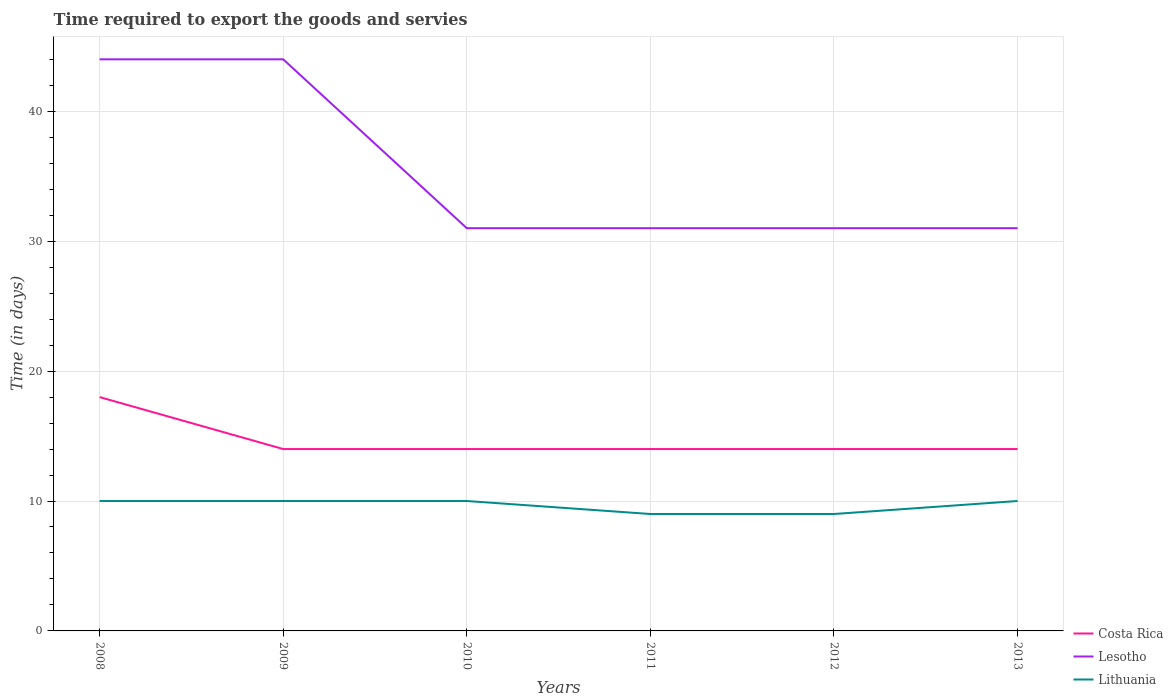Across all years, what is the maximum number of days required to export the goods and services in Lesotho?
Your answer should be very brief. 31. In which year was the number of days required to export the goods and services in Lesotho maximum?
Give a very brief answer. 2010. What is the total number of days required to export the goods and services in Lesotho in the graph?
Ensure brevity in your answer.  13. What is the difference between the highest and the second highest number of days required to export the goods and services in Lithuania?
Provide a short and direct response. 1. Is the number of days required to export the goods and services in Lithuania strictly greater than the number of days required to export the goods and services in Costa Rica over the years?
Provide a short and direct response. Yes. How many lines are there?
Keep it short and to the point. 3. How many years are there in the graph?
Give a very brief answer. 6. What is the difference between two consecutive major ticks on the Y-axis?
Provide a short and direct response. 10. Does the graph contain any zero values?
Your answer should be compact. No. Does the graph contain grids?
Offer a very short reply. Yes. What is the title of the graph?
Your response must be concise. Time required to export the goods and servies. What is the label or title of the X-axis?
Provide a succinct answer. Years. What is the label or title of the Y-axis?
Make the answer very short. Time (in days). What is the Time (in days) in Lithuania in 2008?
Provide a succinct answer. 10. What is the Time (in days) of Costa Rica in 2009?
Your answer should be very brief. 14. What is the Time (in days) of Lesotho in 2009?
Provide a succinct answer. 44. What is the Time (in days) of Costa Rica in 2011?
Provide a short and direct response. 14. What is the Time (in days) of Lesotho in 2012?
Offer a very short reply. 31. What is the Time (in days) of Lithuania in 2012?
Ensure brevity in your answer.  9. What is the Time (in days) in Costa Rica in 2013?
Offer a very short reply. 14. What is the Time (in days) of Lesotho in 2013?
Give a very brief answer. 31. What is the Time (in days) in Lithuania in 2013?
Provide a succinct answer. 10. Across all years, what is the maximum Time (in days) of Costa Rica?
Give a very brief answer. 18. Across all years, what is the maximum Time (in days) of Lesotho?
Keep it short and to the point. 44. Across all years, what is the minimum Time (in days) of Costa Rica?
Keep it short and to the point. 14. Across all years, what is the minimum Time (in days) of Lithuania?
Offer a terse response. 9. What is the total Time (in days) in Costa Rica in the graph?
Give a very brief answer. 88. What is the total Time (in days) of Lesotho in the graph?
Offer a terse response. 212. What is the total Time (in days) of Lithuania in the graph?
Your response must be concise. 58. What is the difference between the Time (in days) in Costa Rica in 2008 and that in 2009?
Give a very brief answer. 4. What is the difference between the Time (in days) of Lesotho in 2008 and that in 2009?
Your answer should be very brief. 0. What is the difference between the Time (in days) in Lithuania in 2008 and that in 2009?
Provide a succinct answer. 0. What is the difference between the Time (in days) of Lesotho in 2008 and that in 2010?
Ensure brevity in your answer.  13. What is the difference between the Time (in days) of Lithuania in 2008 and that in 2010?
Give a very brief answer. 0. What is the difference between the Time (in days) in Costa Rica in 2008 and that in 2011?
Give a very brief answer. 4. What is the difference between the Time (in days) of Lesotho in 2008 and that in 2011?
Your answer should be very brief. 13. What is the difference between the Time (in days) in Lithuania in 2008 and that in 2011?
Your answer should be very brief. 1. What is the difference between the Time (in days) of Costa Rica in 2008 and that in 2013?
Give a very brief answer. 4. What is the difference between the Time (in days) of Lesotho in 2008 and that in 2013?
Keep it short and to the point. 13. What is the difference between the Time (in days) of Lithuania in 2008 and that in 2013?
Your answer should be very brief. 0. What is the difference between the Time (in days) of Costa Rica in 2009 and that in 2010?
Give a very brief answer. 0. What is the difference between the Time (in days) in Lesotho in 2009 and that in 2010?
Provide a succinct answer. 13. What is the difference between the Time (in days) in Lithuania in 2009 and that in 2010?
Make the answer very short. 0. What is the difference between the Time (in days) in Lesotho in 2009 and that in 2011?
Keep it short and to the point. 13. What is the difference between the Time (in days) of Costa Rica in 2009 and that in 2012?
Your answer should be very brief. 0. What is the difference between the Time (in days) of Lesotho in 2009 and that in 2012?
Make the answer very short. 13. What is the difference between the Time (in days) of Lesotho in 2009 and that in 2013?
Offer a terse response. 13. What is the difference between the Time (in days) in Lithuania in 2009 and that in 2013?
Ensure brevity in your answer.  0. What is the difference between the Time (in days) of Lesotho in 2010 and that in 2011?
Give a very brief answer. 0. What is the difference between the Time (in days) in Lithuania in 2010 and that in 2011?
Offer a very short reply. 1. What is the difference between the Time (in days) in Lesotho in 2010 and that in 2012?
Provide a short and direct response. 0. What is the difference between the Time (in days) of Costa Rica in 2011 and that in 2012?
Offer a very short reply. 0. What is the difference between the Time (in days) of Lesotho in 2011 and that in 2012?
Ensure brevity in your answer.  0. What is the difference between the Time (in days) in Lithuania in 2011 and that in 2012?
Provide a succinct answer. 0. What is the difference between the Time (in days) in Costa Rica in 2011 and that in 2013?
Provide a succinct answer. 0. What is the difference between the Time (in days) in Lesotho in 2011 and that in 2013?
Offer a very short reply. 0. What is the difference between the Time (in days) of Costa Rica in 2012 and that in 2013?
Your answer should be very brief. 0. What is the difference between the Time (in days) of Lithuania in 2012 and that in 2013?
Your answer should be compact. -1. What is the difference between the Time (in days) in Costa Rica in 2008 and the Time (in days) in Lithuania in 2009?
Give a very brief answer. 8. What is the difference between the Time (in days) in Costa Rica in 2008 and the Time (in days) in Lesotho in 2010?
Provide a succinct answer. -13. What is the difference between the Time (in days) in Costa Rica in 2008 and the Time (in days) in Lithuania in 2010?
Ensure brevity in your answer.  8. What is the difference between the Time (in days) in Lesotho in 2008 and the Time (in days) in Lithuania in 2010?
Provide a short and direct response. 34. What is the difference between the Time (in days) in Costa Rica in 2008 and the Time (in days) in Lesotho in 2011?
Make the answer very short. -13. What is the difference between the Time (in days) of Lesotho in 2008 and the Time (in days) of Lithuania in 2011?
Keep it short and to the point. 35. What is the difference between the Time (in days) of Costa Rica in 2008 and the Time (in days) of Lesotho in 2012?
Give a very brief answer. -13. What is the difference between the Time (in days) in Costa Rica in 2008 and the Time (in days) in Lesotho in 2013?
Provide a short and direct response. -13. What is the difference between the Time (in days) of Costa Rica in 2008 and the Time (in days) of Lithuania in 2013?
Provide a short and direct response. 8. What is the difference between the Time (in days) of Costa Rica in 2009 and the Time (in days) of Lesotho in 2010?
Your response must be concise. -17. What is the difference between the Time (in days) of Costa Rica in 2009 and the Time (in days) of Lithuania in 2010?
Provide a succinct answer. 4. What is the difference between the Time (in days) of Costa Rica in 2009 and the Time (in days) of Lesotho in 2011?
Your answer should be very brief. -17. What is the difference between the Time (in days) of Lesotho in 2009 and the Time (in days) of Lithuania in 2011?
Give a very brief answer. 35. What is the difference between the Time (in days) of Costa Rica in 2009 and the Time (in days) of Lithuania in 2012?
Provide a succinct answer. 5. What is the difference between the Time (in days) of Costa Rica in 2009 and the Time (in days) of Lesotho in 2013?
Ensure brevity in your answer.  -17. What is the difference between the Time (in days) in Lesotho in 2009 and the Time (in days) in Lithuania in 2013?
Keep it short and to the point. 34. What is the difference between the Time (in days) of Costa Rica in 2010 and the Time (in days) of Lesotho in 2012?
Ensure brevity in your answer.  -17. What is the difference between the Time (in days) in Lesotho in 2010 and the Time (in days) in Lithuania in 2012?
Provide a succinct answer. 22. What is the difference between the Time (in days) of Costa Rica in 2010 and the Time (in days) of Lesotho in 2013?
Provide a succinct answer. -17. What is the difference between the Time (in days) of Costa Rica in 2010 and the Time (in days) of Lithuania in 2013?
Your response must be concise. 4. What is the difference between the Time (in days) of Costa Rica in 2011 and the Time (in days) of Lithuania in 2012?
Keep it short and to the point. 5. What is the difference between the Time (in days) in Costa Rica in 2011 and the Time (in days) in Lesotho in 2013?
Provide a short and direct response. -17. What is the difference between the Time (in days) of Costa Rica in 2012 and the Time (in days) of Lesotho in 2013?
Provide a succinct answer. -17. What is the difference between the Time (in days) in Costa Rica in 2012 and the Time (in days) in Lithuania in 2013?
Offer a terse response. 4. What is the average Time (in days) in Costa Rica per year?
Your answer should be very brief. 14.67. What is the average Time (in days) in Lesotho per year?
Provide a short and direct response. 35.33. What is the average Time (in days) of Lithuania per year?
Offer a terse response. 9.67. In the year 2008, what is the difference between the Time (in days) in Costa Rica and Time (in days) in Lesotho?
Your response must be concise. -26. In the year 2008, what is the difference between the Time (in days) in Lesotho and Time (in days) in Lithuania?
Ensure brevity in your answer.  34. In the year 2009, what is the difference between the Time (in days) of Costa Rica and Time (in days) of Lesotho?
Offer a terse response. -30. In the year 2010, what is the difference between the Time (in days) in Costa Rica and Time (in days) in Lesotho?
Make the answer very short. -17. In the year 2010, what is the difference between the Time (in days) in Costa Rica and Time (in days) in Lithuania?
Keep it short and to the point. 4. In the year 2011, what is the difference between the Time (in days) of Costa Rica and Time (in days) of Lithuania?
Provide a short and direct response. 5. In the year 2011, what is the difference between the Time (in days) of Lesotho and Time (in days) of Lithuania?
Your response must be concise. 22. In the year 2012, what is the difference between the Time (in days) in Lesotho and Time (in days) in Lithuania?
Make the answer very short. 22. What is the ratio of the Time (in days) of Costa Rica in 2008 to that in 2009?
Make the answer very short. 1.29. What is the ratio of the Time (in days) of Lesotho in 2008 to that in 2009?
Ensure brevity in your answer.  1. What is the ratio of the Time (in days) in Lithuania in 2008 to that in 2009?
Provide a succinct answer. 1. What is the ratio of the Time (in days) in Costa Rica in 2008 to that in 2010?
Offer a terse response. 1.29. What is the ratio of the Time (in days) in Lesotho in 2008 to that in 2010?
Ensure brevity in your answer.  1.42. What is the ratio of the Time (in days) of Costa Rica in 2008 to that in 2011?
Ensure brevity in your answer.  1.29. What is the ratio of the Time (in days) of Lesotho in 2008 to that in 2011?
Your answer should be compact. 1.42. What is the ratio of the Time (in days) in Lithuania in 2008 to that in 2011?
Your answer should be very brief. 1.11. What is the ratio of the Time (in days) in Lesotho in 2008 to that in 2012?
Provide a succinct answer. 1.42. What is the ratio of the Time (in days) of Lithuania in 2008 to that in 2012?
Keep it short and to the point. 1.11. What is the ratio of the Time (in days) of Costa Rica in 2008 to that in 2013?
Your response must be concise. 1.29. What is the ratio of the Time (in days) of Lesotho in 2008 to that in 2013?
Keep it short and to the point. 1.42. What is the ratio of the Time (in days) in Lithuania in 2008 to that in 2013?
Offer a terse response. 1. What is the ratio of the Time (in days) of Costa Rica in 2009 to that in 2010?
Your response must be concise. 1. What is the ratio of the Time (in days) in Lesotho in 2009 to that in 2010?
Provide a short and direct response. 1.42. What is the ratio of the Time (in days) of Lithuania in 2009 to that in 2010?
Offer a terse response. 1. What is the ratio of the Time (in days) in Costa Rica in 2009 to that in 2011?
Your answer should be compact. 1. What is the ratio of the Time (in days) of Lesotho in 2009 to that in 2011?
Make the answer very short. 1.42. What is the ratio of the Time (in days) in Costa Rica in 2009 to that in 2012?
Offer a very short reply. 1. What is the ratio of the Time (in days) in Lesotho in 2009 to that in 2012?
Offer a terse response. 1.42. What is the ratio of the Time (in days) in Costa Rica in 2009 to that in 2013?
Your answer should be very brief. 1. What is the ratio of the Time (in days) of Lesotho in 2009 to that in 2013?
Your answer should be very brief. 1.42. What is the ratio of the Time (in days) of Lithuania in 2009 to that in 2013?
Ensure brevity in your answer.  1. What is the ratio of the Time (in days) of Costa Rica in 2010 to that in 2011?
Offer a very short reply. 1. What is the ratio of the Time (in days) of Lesotho in 2010 to that in 2011?
Offer a terse response. 1. What is the ratio of the Time (in days) of Costa Rica in 2010 to that in 2013?
Your answer should be very brief. 1. What is the ratio of the Time (in days) of Lesotho in 2010 to that in 2013?
Your response must be concise. 1. What is the ratio of the Time (in days) of Lithuania in 2010 to that in 2013?
Keep it short and to the point. 1. What is the ratio of the Time (in days) in Costa Rica in 2011 to that in 2012?
Keep it short and to the point. 1. What is the ratio of the Time (in days) in Lesotho in 2011 to that in 2013?
Your answer should be very brief. 1. What is the ratio of the Time (in days) of Lithuania in 2011 to that in 2013?
Provide a succinct answer. 0.9. What is the ratio of the Time (in days) of Lesotho in 2012 to that in 2013?
Your answer should be compact. 1. What is the ratio of the Time (in days) of Lithuania in 2012 to that in 2013?
Your answer should be compact. 0.9. What is the difference between the highest and the second highest Time (in days) of Costa Rica?
Provide a short and direct response. 4. What is the difference between the highest and the second highest Time (in days) of Lesotho?
Your response must be concise. 0. What is the difference between the highest and the lowest Time (in days) in Costa Rica?
Provide a short and direct response. 4. 